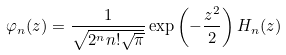<formula> <loc_0><loc_0><loc_500><loc_500>\varphi _ { n } ( z ) = \frac { 1 } { \sqrt { 2 ^ { n } n ! \sqrt { \pi } } } \exp \left ( - \frac { z ^ { 2 } } { 2 } \right ) H _ { n } ( z )</formula> 